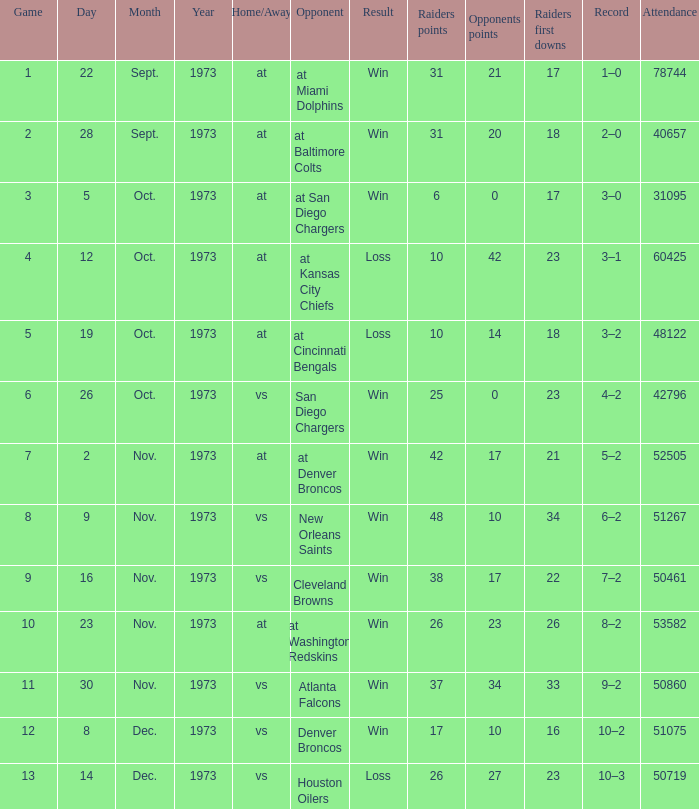Can you give me this table as a dict? {'header': ['Game', 'Day', 'Month', 'Year', 'Home/Away', 'Opponent', 'Result', 'Raiders points', 'Opponents points', 'Raiders first downs', 'Record', 'Attendance'], 'rows': [['1', '22', 'Sept.', '1973', 'at', 'at Miami Dolphins', 'Win', '31', '21', '17', '1–0', '78744'], ['2', '28', 'Sept.', '1973', 'at', 'at Baltimore Colts', 'Win', '31', '20', '18', '2–0', '40657'], ['3', '5', 'Oct.', '1973', 'at', 'at San Diego Chargers', 'Win', '6', '0', '17', '3–0', '31095'], ['4', '12', 'Oct.', '1973', 'at', 'at Kansas City Chiefs', 'Loss', '10', '42', '23', '3–1', '60425'], ['5', '19', 'Oct.', '1973', 'at', 'at Cincinnati Bengals', 'Loss', '10', '14', '18', '3–2', '48122'], ['6', '26', 'Oct.', '1973', 'vs', 'San Diego Chargers', 'Win', '25', '0', '23', '4–2', '42796'], ['7', '2', 'Nov.', '1973', 'at', 'at Denver Broncos', 'Win', '42', '17', '21', '5–2', '52505'], ['8', '9', 'Nov.', '1973', 'vs', 'New Orleans Saints', 'Win', '48', '10', '34', '6–2', '51267'], ['9', '16', 'Nov.', '1973', 'vs', 'Cleveland Browns', 'Win', '38', '17', '22', '7–2', '50461'], ['10', '23', 'Nov.', '1973', 'at', 'at Washington Redskins', 'Win', '26', '23', '26', '8–2', '53582'], ['11', '30', 'Nov.', '1973', 'vs', 'Atlanta Falcons', 'Win', '37', '34', '33', '9–2', '50860'], ['12', '8', 'Dec.', '1973', 'vs', 'Denver Broncos', 'Win', '17', '10', '16', '10–2', '51075'], ['13', '14', 'Dec.', '1973', 'vs', 'Houston Oilers', 'Loss', '26', '27', '23', '10–3', '50719']]} How many opponents played 1 game with a result win? 21.0. 